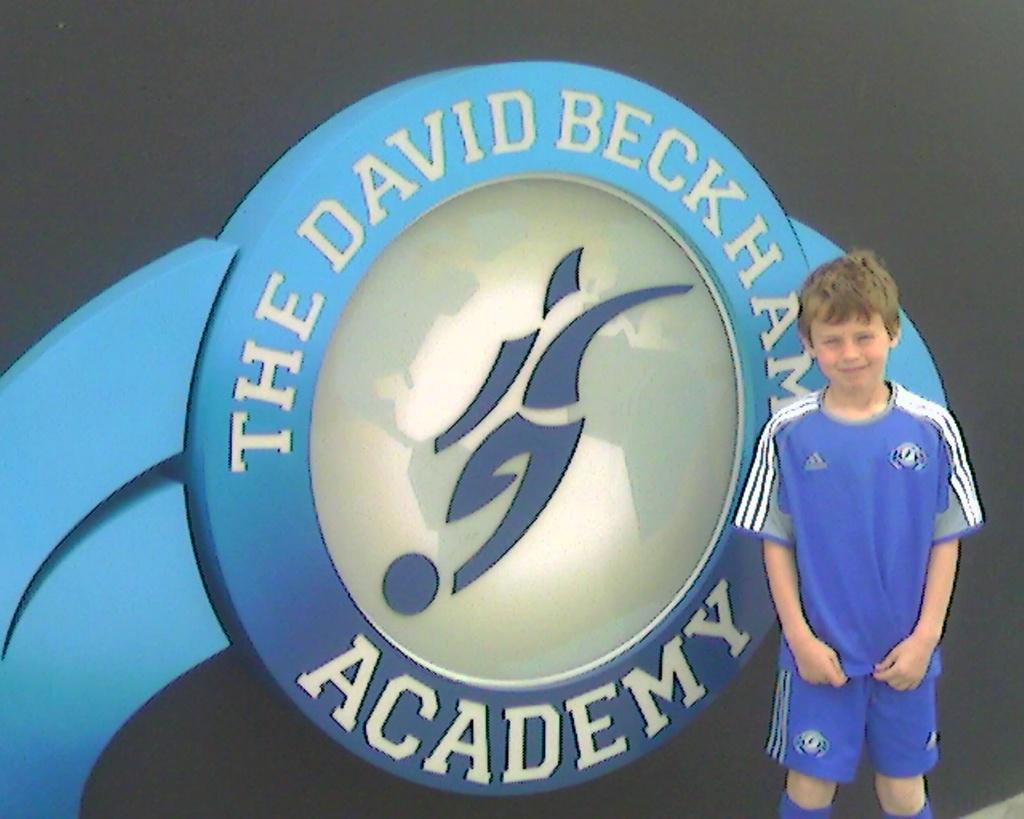Who's academy is this?
Your answer should be very brief. David beckham. 